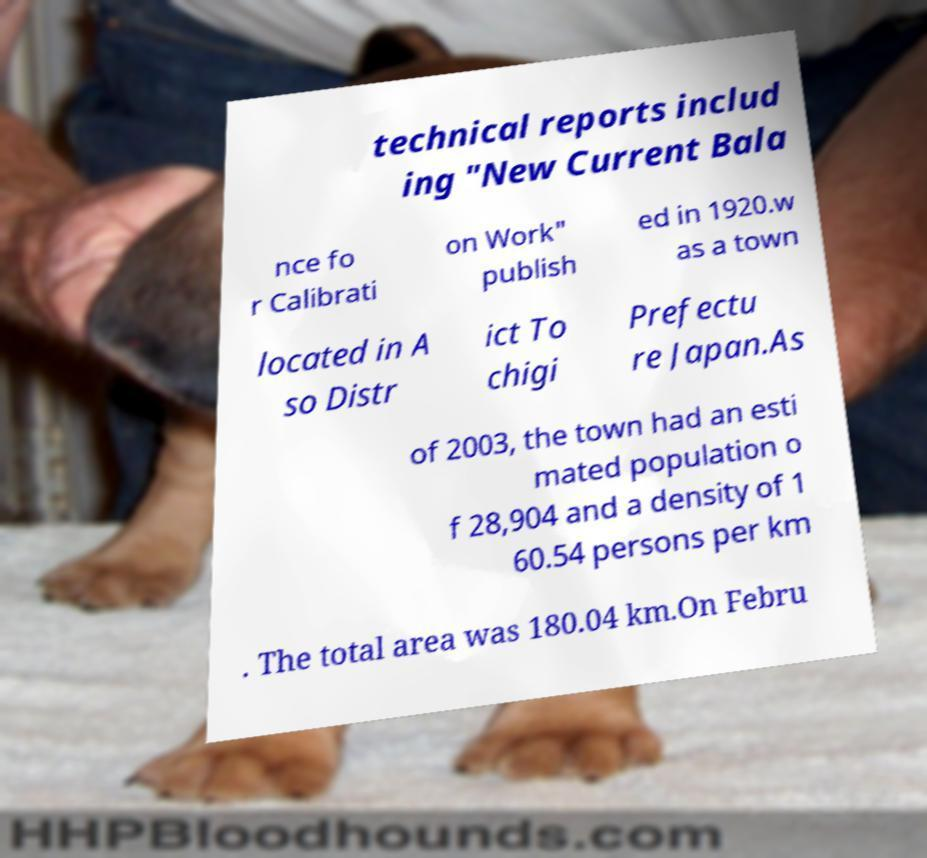What messages or text are displayed in this image? I need them in a readable, typed format. technical reports includ ing "New Current Bala nce fo r Calibrati on Work" publish ed in 1920.w as a town located in A so Distr ict To chigi Prefectu re Japan.As of 2003, the town had an esti mated population o f 28,904 and a density of 1 60.54 persons per km . The total area was 180.04 km.On Febru 